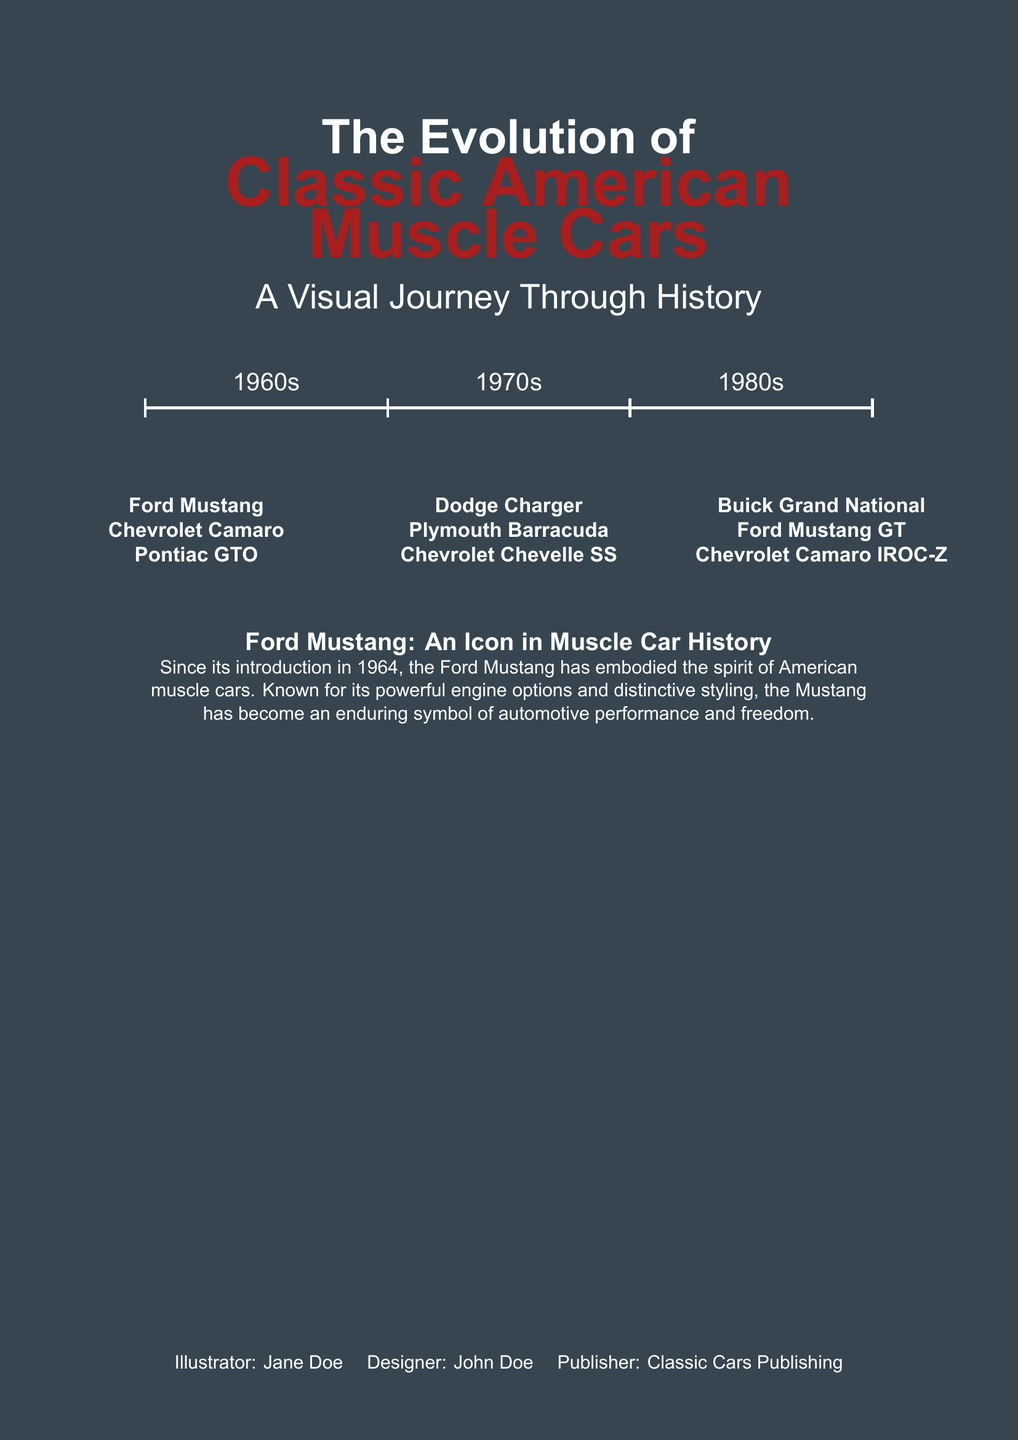What is the title of the book? The title can be found at the top of the cover and details the subject matter of the book.
Answer: The Evolution of Classic American Muscle Cars: A Visual Journey Through History Who illustrated the book cover? The illustrator's name is provided at the bottom of the cover, indicating who created the visual aspects.
Answer: Jane Doe Which iconic car is mentioned first on the cover? The first car listed is a prominent figure in muscle car history, found in the multicols section.
Answer: Ford Mustang What decades are highlighted on the timeline? The timeline sections on the cover indicate the specific decades covered in the book.
Answer: 1960s, 1970s, 1980s What type of vehicle is the focus of this book? The subject of the book is specifically described in the title, highlighting a particular category of automobiles.
Answer: Muscle cars How many cars are listed in total on the cover? By counting the entries in the multicols section, one can determine the total number of iconic cars featured.
Answer: Nine What color is predominantly used for the title text? The color theme of the cover is distinctive, especially for the title, and can be noted visually.
Answer: Mustang red What publisher is associated with the book? The name of the publisher is included at the bottom of the cover, providing information on who released the book.
Answer: Classic Cars Publishing What kind of visuals does the book provide according to the subtitle? The subtitle includes a descriptor that tells what type of visuals readers can expect from the book.
Answer: A Visual Journey Through History 